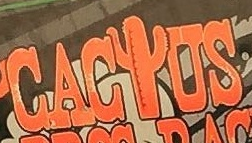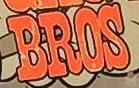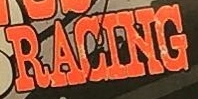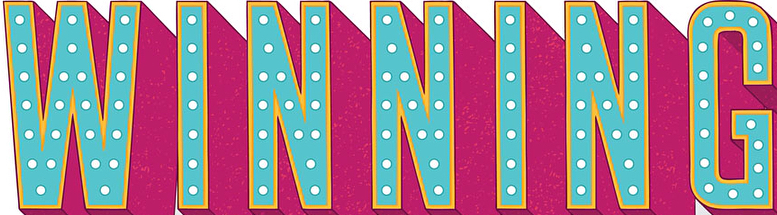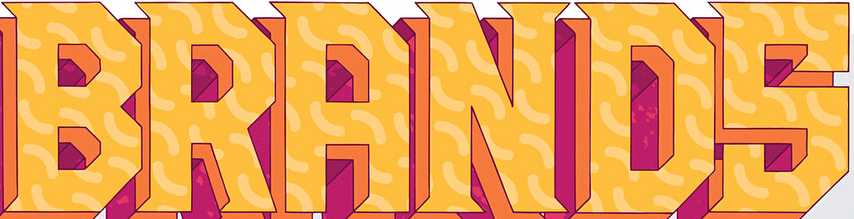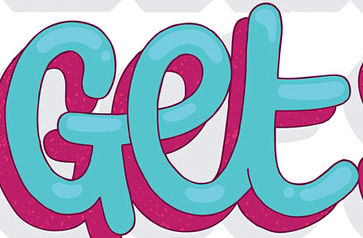Read the text from these images in sequence, separated by a semicolon. CACIUS; BROS; RACING; WINNING; BRANDS; Get 